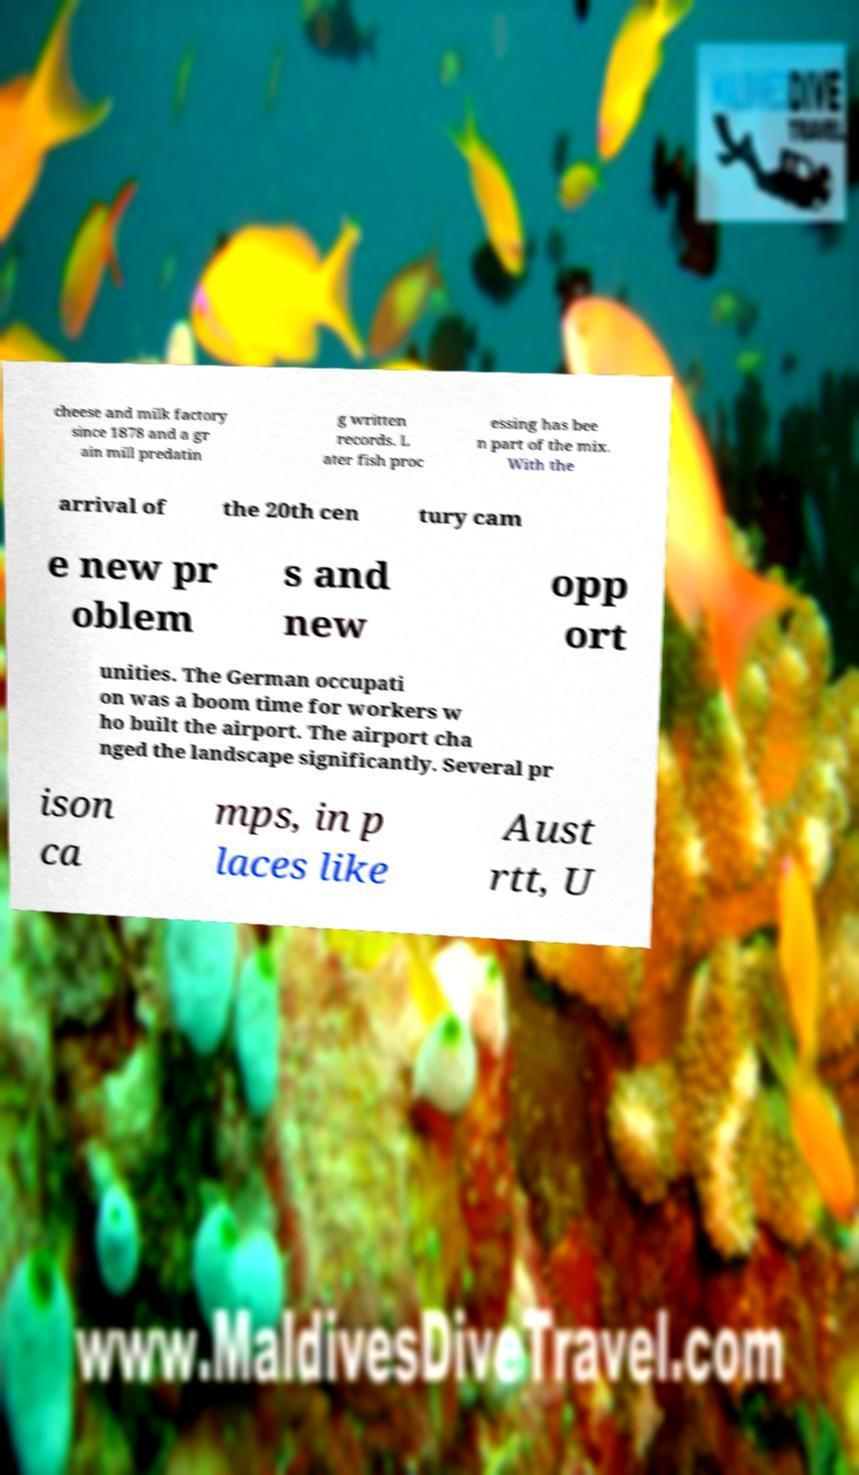I need the written content from this picture converted into text. Can you do that? cheese and milk factory since 1878 and a gr ain mill predatin g written records. L ater fish proc essing has bee n part of the mix. With the arrival of the 20th cen tury cam e new pr oblem s and new opp ort unities. The German occupati on was a boom time for workers w ho built the airport. The airport cha nged the landscape significantly. Several pr ison ca mps, in p laces like Aust rtt, U 